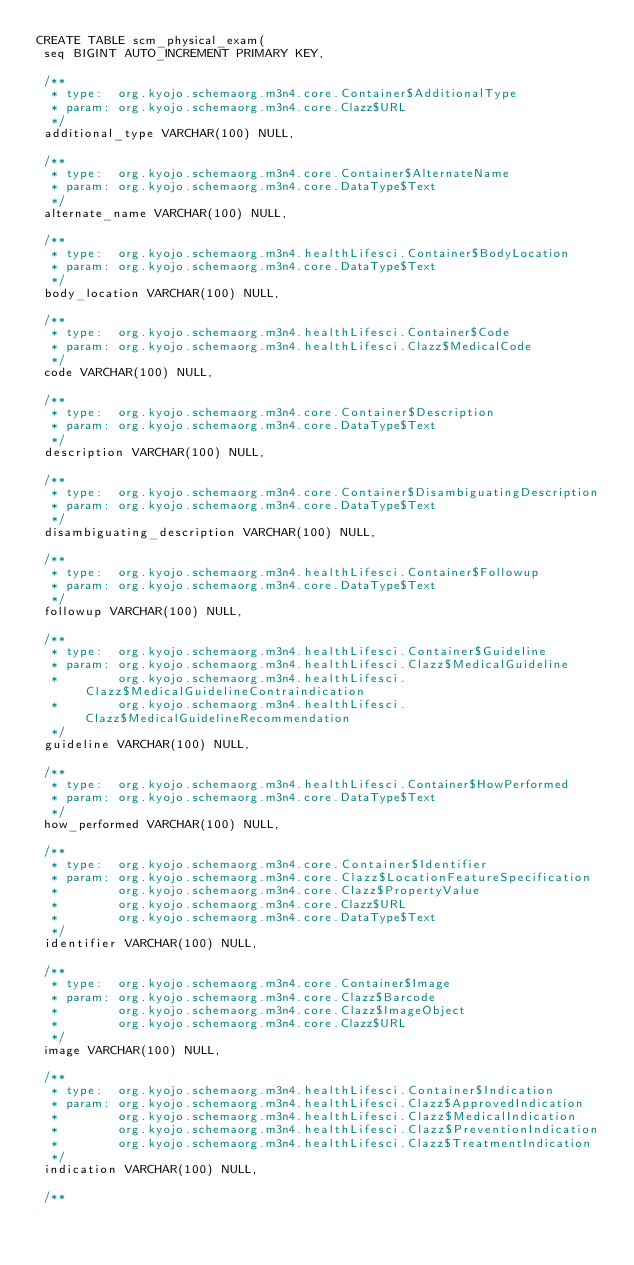<code> <loc_0><loc_0><loc_500><loc_500><_SQL_>CREATE TABLE scm_physical_exam(
 seq BIGINT AUTO_INCREMENT PRIMARY KEY,

 /**
  * type:  org.kyojo.schemaorg.m3n4.core.Container$AdditionalType
  * param: org.kyojo.schemaorg.m3n4.core.Clazz$URL
  */
 additional_type VARCHAR(100) NULL,

 /**
  * type:  org.kyojo.schemaorg.m3n4.core.Container$AlternateName
  * param: org.kyojo.schemaorg.m3n4.core.DataType$Text
  */
 alternate_name VARCHAR(100) NULL,

 /**
  * type:  org.kyojo.schemaorg.m3n4.healthLifesci.Container$BodyLocation
  * param: org.kyojo.schemaorg.m3n4.core.DataType$Text
  */
 body_location VARCHAR(100) NULL,

 /**
  * type:  org.kyojo.schemaorg.m3n4.healthLifesci.Container$Code
  * param: org.kyojo.schemaorg.m3n4.healthLifesci.Clazz$MedicalCode
  */
 code VARCHAR(100) NULL,

 /**
  * type:  org.kyojo.schemaorg.m3n4.core.Container$Description
  * param: org.kyojo.schemaorg.m3n4.core.DataType$Text
  */
 description VARCHAR(100) NULL,

 /**
  * type:  org.kyojo.schemaorg.m3n4.core.Container$DisambiguatingDescription
  * param: org.kyojo.schemaorg.m3n4.core.DataType$Text
  */
 disambiguating_description VARCHAR(100) NULL,

 /**
  * type:  org.kyojo.schemaorg.m3n4.healthLifesci.Container$Followup
  * param: org.kyojo.schemaorg.m3n4.core.DataType$Text
  */
 followup VARCHAR(100) NULL,

 /**
  * type:  org.kyojo.schemaorg.m3n4.healthLifesci.Container$Guideline
  * param: org.kyojo.schemaorg.m3n4.healthLifesci.Clazz$MedicalGuideline
  *        org.kyojo.schemaorg.m3n4.healthLifesci.Clazz$MedicalGuidelineContraindication
  *        org.kyojo.schemaorg.m3n4.healthLifesci.Clazz$MedicalGuidelineRecommendation
  */
 guideline VARCHAR(100) NULL,

 /**
  * type:  org.kyojo.schemaorg.m3n4.healthLifesci.Container$HowPerformed
  * param: org.kyojo.schemaorg.m3n4.core.DataType$Text
  */
 how_performed VARCHAR(100) NULL,

 /**
  * type:  org.kyojo.schemaorg.m3n4.core.Container$Identifier
  * param: org.kyojo.schemaorg.m3n4.core.Clazz$LocationFeatureSpecification
  *        org.kyojo.schemaorg.m3n4.core.Clazz$PropertyValue
  *        org.kyojo.schemaorg.m3n4.core.Clazz$URL
  *        org.kyojo.schemaorg.m3n4.core.DataType$Text
  */
 identifier VARCHAR(100) NULL,

 /**
  * type:  org.kyojo.schemaorg.m3n4.core.Container$Image
  * param: org.kyojo.schemaorg.m3n4.core.Clazz$Barcode
  *        org.kyojo.schemaorg.m3n4.core.Clazz$ImageObject
  *        org.kyojo.schemaorg.m3n4.core.Clazz$URL
  */
 image VARCHAR(100) NULL,

 /**
  * type:  org.kyojo.schemaorg.m3n4.healthLifesci.Container$Indication
  * param: org.kyojo.schemaorg.m3n4.healthLifesci.Clazz$ApprovedIndication
  *        org.kyojo.schemaorg.m3n4.healthLifesci.Clazz$MedicalIndication
  *        org.kyojo.schemaorg.m3n4.healthLifesci.Clazz$PreventionIndication
  *        org.kyojo.schemaorg.m3n4.healthLifesci.Clazz$TreatmentIndication
  */
 indication VARCHAR(100) NULL,

 /**</code> 